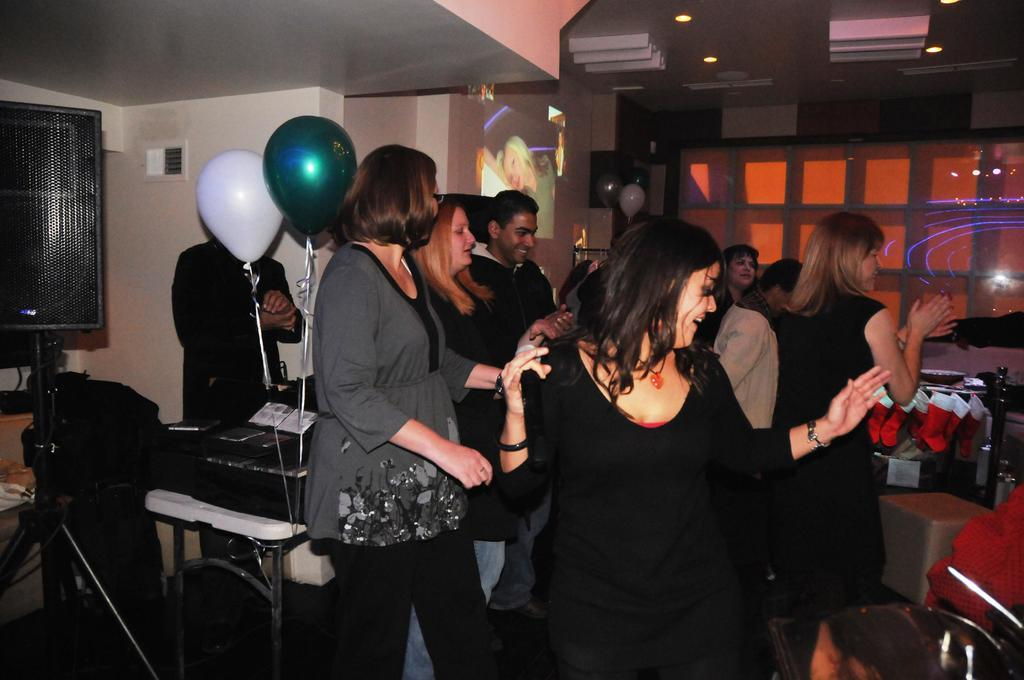What can be seen in the image involving people? There are people standing in the image. What is attached to the table in the image? There are balloons tied to a table in the image. What is on the wall in the image? There is a projector screen on the wall in the image. How much dirt is visible on the projector screen in the image? There is no dirt visible on the projector screen in the image. Is there any money being exchanged between the people in the image? The provided facts do not mention any money being exchanged between the people in the image. Can you tell me how many cents are on the table with the balloons? There are no cents visible on the table with the balloons in the image. 